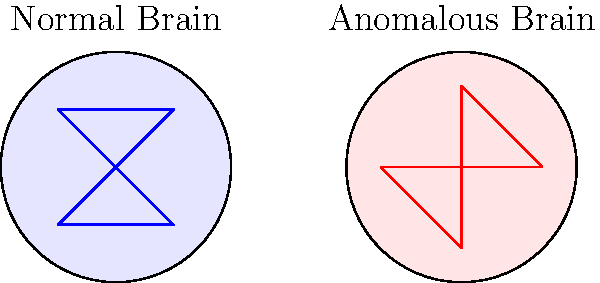Given the graph representations of a normal brain and an anomalous brain, which brain exhibits higher global efficiency in terms of information flow? Explain your reasoning using graph theory concepts. To compare the efficiency of information flow in the two brain networks, we need to consider the concept of global efficiency in graph theory. Here's a step-by-step analysis:

1. Global Efficiency: This measure quantifies how efficiently information is exchanged across the entire network. It is inversely related to the average shortest path length between all pairs of nodes.

2. Normal Brain:
   - Has a more centralized structure with a hub node (center)
   - Shorter average path length between nodes
   - More connections between peripheral nodes

3. Anomalous Brain:
   - Has a more distributed structure
   - Longer average path length between some nodes
   - Fewer connections between peripheral nodes

4. Path Length Analysis:
   - Normal Brain: Most nodes can reach each other in 1-2 steps
   - Anomalous Brain: Some nodes require 3 steps to reach each other

5. Connectivity Analysis:
   - Normal Brain: 6 connections for 5 nodes
   - Anomalous Brain: 5 connections for 5 nodes

6. Information Flow:
   - Normal Brain: Information can flow more directly between most nodes
   - Anomalous Brain: Information often needs to pass through the central node

7. Resilience:
   - Normal Brain: More resilient to single node failure due to alternative paths
   - Anomalous Brain: More vulnerable to central node failure

Based on these observations, the normal brain exhibits higher global efficiency in terms of information flow. It has shorter average path lengths and more direct connections between nodes, allowing for faster and more robust information exchange across the network.
Answer: The normal brain exhibits higher global efficiency. 